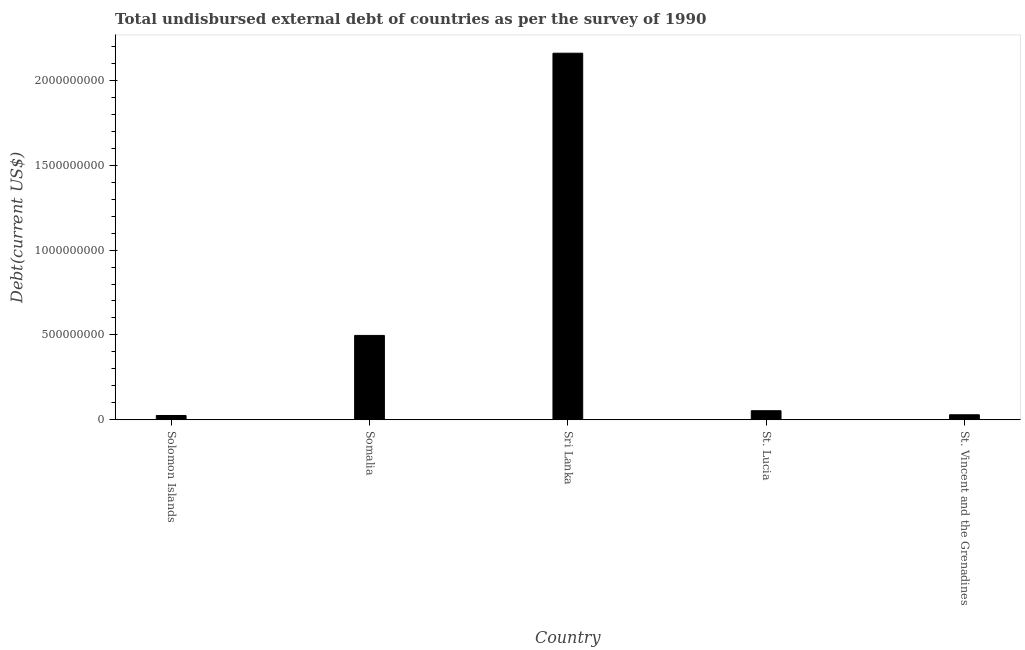Does the graph contain grids?
Keep it short and to the point. No. What is the title of the graph?
Your answer should be very brief. Total undisbursed external debt of countries as per the survey of 1990. What is the label or title of the Y-axis?
Offer a very short reply. Debt(current US$). What is the total debt in Solomon Islands?
Offer a very short reply. 2.54e+07. Across all countries, what is the maximum total debt?
Your answer should be very brief. 2.16e+09. Across all countries, what is the minimum total debt?
Ensure brevity in your answer.  2.54e+07. In which country was the total debt maximum?
Ensure brevity in your answer.  Sri Lanka. In which country was the total debt minimum?
Offer a very short reply. Solomon Islands. What is the sum of the total debt?
Your answer should be compact. 2.77e+09. What is the difference between the total debt in St. Lucia and St. Vincent and the Grenadines?
Ensure brevity in your answer.  2.39e+07. What is the average total debt per country?
Provide a succinct answer. 5.53e+08. What is the median total debt?
Provide a succinct answer. 5.35e+07. In how many countries, is the total debt greater than 1600000000 US$?
Provide a short and direct response. 1. What is the ratio of the total debt in Solomon Islands to that in St. Lucia?
Offer a very short reply. 0.47. Is the difference between the total debt in St. Lucia and St. Vincent and the Grenadines greater than the difference between any two countries?
Your response must be concise. No. What is the difference between the highest and the second highest total debt?
Offer a terse response. 1.66e+09. Is the sum of the total debt in Somalia and Sri Lanka greater than the maximum total debt across all countries?
Provide a succinct answer. Yes. What is the difference between the highest and the lowest total debt?
Provide a short and direct response. 2.13e+09. Are all the bars in the graph horizontal?
Offer a very short reply. No. What is the difference between two consecutive major ticks on the Y-axis?
Your answer should be compact. 5.00e+08. Are the values on the major ticks of Y-axis written in scientific E-notation?
Offer a terse response. No. What is the Debt(current US$) in Solomon Islands?
Make the answer very short. 2.54e+07. What is the Debt(current US$) of Somalia?
Give a very brief answer. 4.97e+08. What is the Debt(current US$) in Sri Lanka?
Your response must be concise. 2.16e+09. What is the Debt(current US$) in St. Lucia?
Offer a very short reply. 5.35e+07. What is the Debt(current US$) of St. Vincent and the Grenadines?
Offer a terse response. 2.96e+07. What is the difference between the Debt(current US$) in Solomon Islands and Somalia?
Provide a short and direct response. -4.72e+08. What is the difference between the Debt(current US$) in Solomon Islands and Sri Lanka?
Make the answer very short. -2.13e+09. What is the difference between the Debt(current US$) in Solomon Islands and St. Lucia?
Make the answer very short. -2.81e+07. What is the difference between the Debt(current US$) in Solomon Islands and St. Vincent and the Grenadines?
Ensure brevity in your answer.  -4.25e+06. What is the difference between the Debt(current US$) in Somalia and Sri Lanka?
Offer a very short reply. -1.66e+09. What is the difference between the Debt(current US$) in Somalia and St. Lucia?
Keep it short and to the point. 4.44e+08. What is the difference between the Debt(current US$) in Somalia and St. Vincent and the Grenadines?
Your response must be concise. 4.68e+08. What is the difference between the Debt(current US$) in Sri Lanka and St. Lucia?
Your answer should be very brief. 2.11e+09. What is the difference between the Debt(current US$) in Sri Lanka and St. Vincent and the Grenadines?
Your response must be concise. 2.13e+09. What is the difference between the Debt(current US$) in St. Lucia and St. Vincent and the Grenadines?
Make the answer very short. 2.39e+07. What is the ratio of the Debt(current US$) in Solomon Islands to that in Somalia?
Your answer should be compact. 0.05. What is the ratio of the Debt(current US$) in Solomon Islands to that in Sri Lanka?
Provide a short and direct response. 0.01. What is the ratio of the Debt(current US$) in Solomon Islands to that in St. Lucia?
Keep it short and to the point. 0.47. What is the ratio of the Debt(current US$) in Solomon Islands to that in St. Vincent and the Grenadines?
Make the answer very short. 0.86. What is the ratio of the Debt(current US$) in Somalia to that in Sri Lanka?
Make the answer very short. 0.23. What is the ratio of the Debt(current US$) in Somalia to that in St. Lucia?
Provide a succinct answer. 9.29. What is the ratio of the Debt(current US$) in Somalia to that in St. Vincent and the Grenadines?
Provide a short and direct response. 16.77. What is the ratio of the Debt(current US$) in Sri Lanka to that in St. Lucia?
Offer a very short reply. 40.36. What is the ratio of the Debt(current US$) in Sri Lanka to that in St. Vincent and the Grenadines?
Your answer should be very brief. 72.86. What is the ratio of the Debt(current US$) in St. Lucia to that in St. Vincent and the Grenadines?
Ensure brevity in your answer.  1.8. 